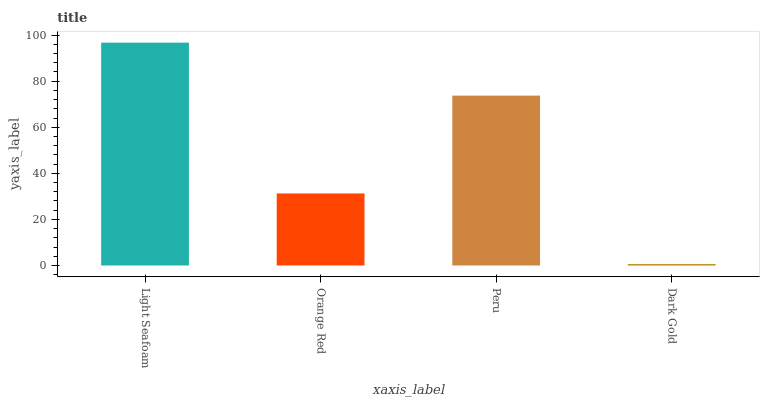Is Dark Gold the minimum?
Answer yes or no. Yes. Is Light Seafoam the maximum?
Answer yes or no. Yes. Is Orange Red the minimum?
Answer yes or no. No. Is Orange Red the maximum?
Answer yes or no. No. Is Light Seafoam greater than Orange Red?
Answer yes or no. Yes. Is Orange Red less than Light Seafoam?
Answer yes or no. Yes. Is Orange Red greater than Light Seafoam?
Answer yes or no. No. Is Light Seafoam less than Orange Red?
Answer yes or no. No. Is Peru the high median?
Answer yes or no. Yes. Is Orange Red the low median?
Answer yes or no. Yes. Is Orange Red the high median?
Answer yes or no. No. Is Dark Gold the low median?
Answer yes or no. No. 